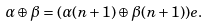<formula> <loc_0><loc_0><loc_500><loc_500>\alpha \oplus \beta = ( \alpha ( n + 1 ) \oplus \beta ( n + 1 ) ) e .</formula> 